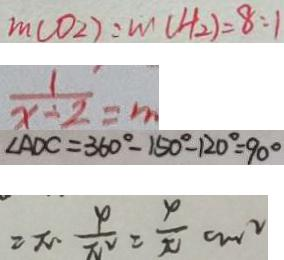<formula> <loc_0><loc_0><loc_500><loc_500>m ( O _ { 2 } ) : m ( H _ { 2 } ) = 8 : 1 
 \frac { 1 } { x + 2 } = m 
 \angle A D C = 3 6 0 ^ { \circ } - 1 5 0 ^ { \circ } - 1 2 0 ^ { \circ } = 9 0 ^ { \circ } 
 = \pi \frac { 4 } { \pi ^ { 2 } } = \frac { 4 } { \pi } c m ^ { 2 }</formula> 